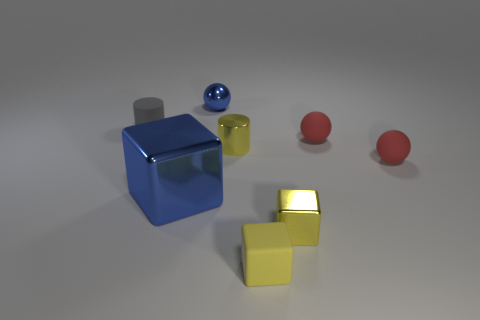There is a metal block that is left of the yellow shiny thing that is in front of the blue block to the left of the yellow matte cube; how big is it?
Give a very brief answer. Large. How many things are blocks that are to the right of the small yellow rubber cube or big blue things?
Offer a very short reply. 2. What number of tiny gray rubber things are behind the yellow shiny object that is in front of the tiny yellow metal cylinder?
Ensure brevity in your answer.  1. Is the number of tiny yellow metallic objects in front of the tiny blue shiny ball greater than the number of small red things?
Ensure brevity in your answer.  No. What size is the thing that is on the right side of the small matte block and in front of the big blue metal object?
Give a very brief answer. Small. There is a thing that is both in front of the big shiny cube and right of the tiny rubber cube; what is its shape?
Keep it short and to the point. Cube. There is a small sphere that is behind the matte object that is on the left side of the rubber cube; is there a yellow thing behind it?
Keep it short and to the point. No. How many things are tiny cylinders that are on the right side of the tiny rubber cylinder or tiny spheres to the left of the yellow shiny block?
Offer a terse response. 2. Does the small cylinder that is in front of the tiny gray object have the same material as the big block?
Provide a short and direct response. Yes. What is the material of the object that is to the left of the small metal ball and to the right of the small gray object?
Your response must be concise. Metal. 